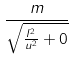Convert formula to latex. <formula><loc_0><loc_0><loc_500><loc_500>\frac { m } { \sqrt { \frac { l ^ { 2 } } { u ^ { 2 } } + 0 } }</formula> 